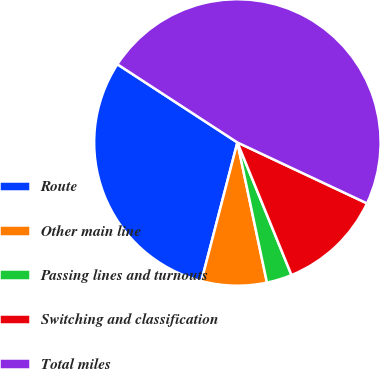Convert chart to OTSL. <chart><loc_0><loc_0><loc_500><loc_500><pie_chart><fcel>Route<fcel>Other main line<fcel>Passing lines and turnouts<fcel>Switching and classification<fcel>Total miles<nl><fcel>30.15%<fcel>7.35%<fcel>2.86%<fcel>11.84%<fcel>47.8%<nl></chart> 